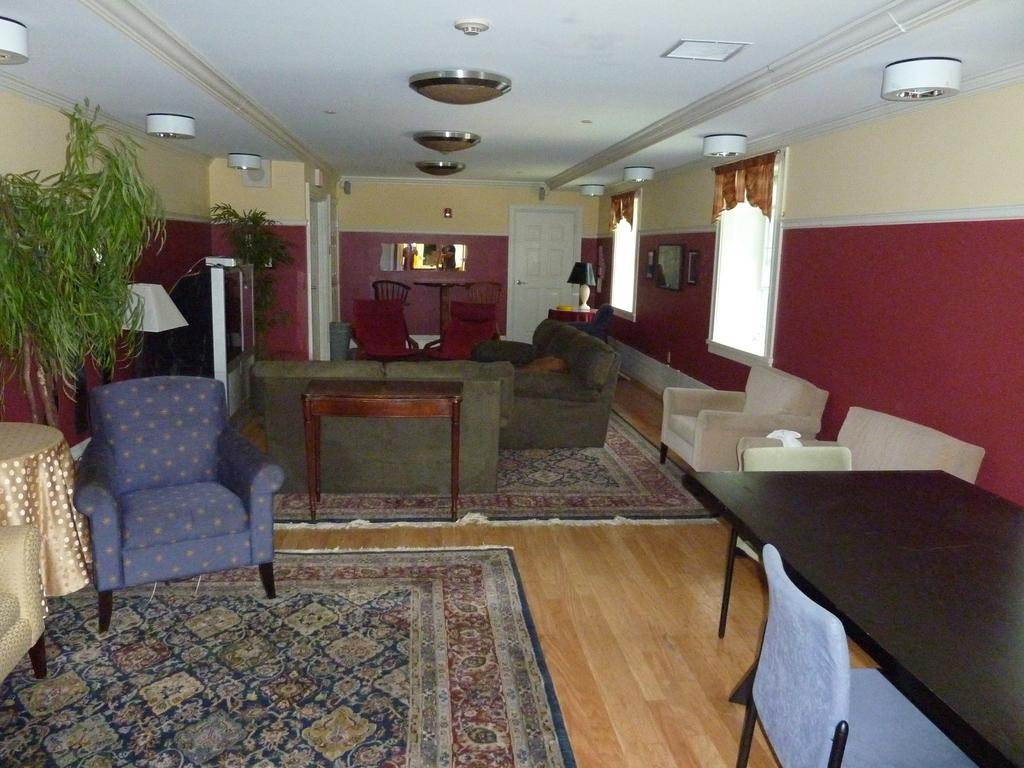What type of space is depicted in the image? There is a room in the image. What furniture is present in the room? There is a sofa set in the room. How many tables are in the room? There are 2 tables in the room. What architectural features allow for natural light and ventilation? There are windows in the room. How can one enter or exit the room? There are doors in the room. What type of decorative or natural elements are present in the room? There are plants in the room. What type of shop can be seen in the image? There is no shop present in the image; it depicts a room with furniture and plants. 